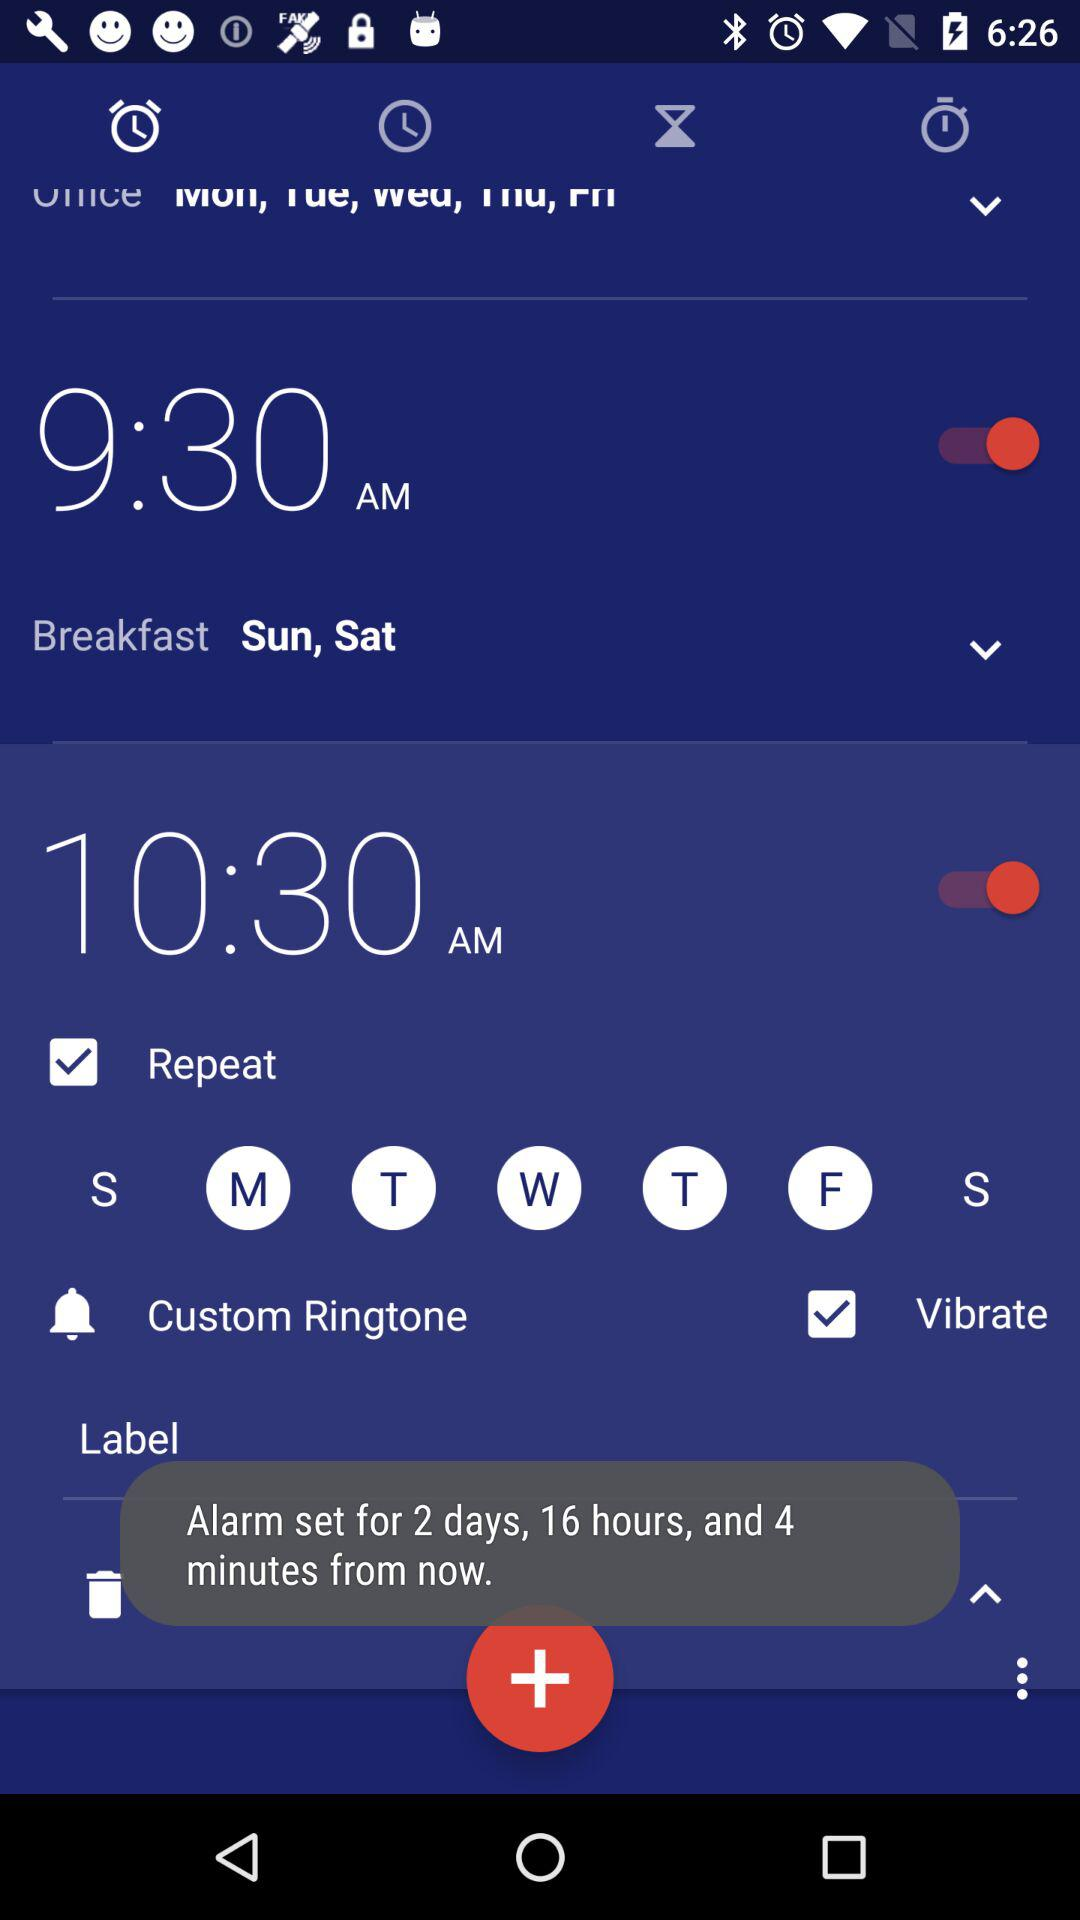What is the selected day for breakfast? The selected days are Saturday and Sunday. 